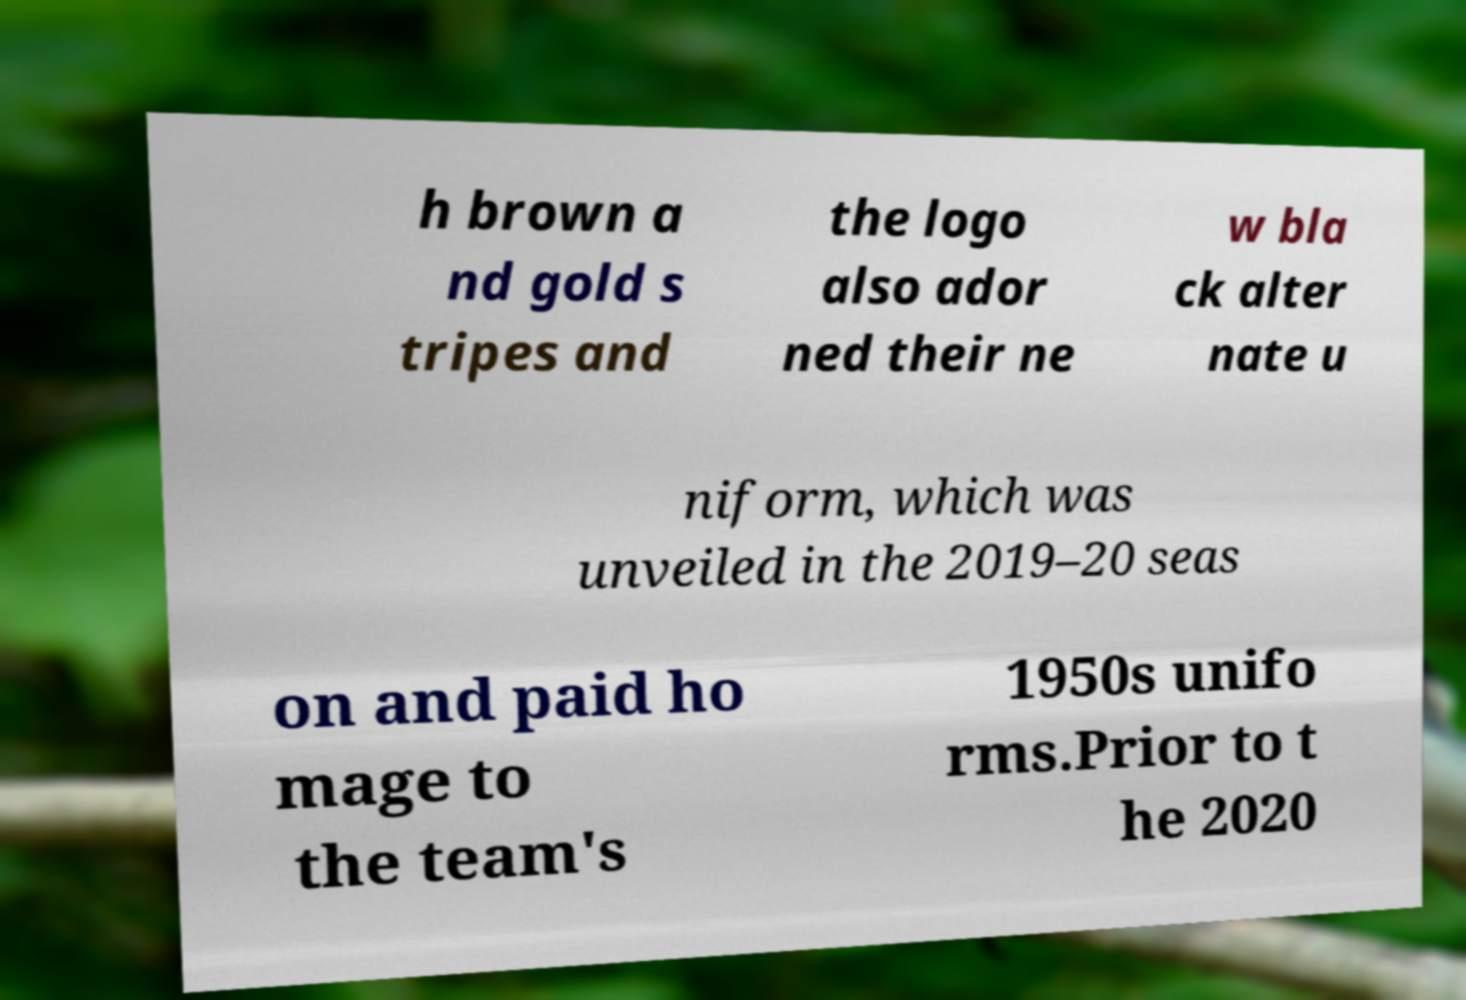Please read and relay the text visible in this image. What does it say? h brown a nd gold s tripes and the logo also ador ned their ne w bla ck alter nate u niform, which was unveiled in the 2019–20 seas on and paid ho mage to the team's 1950s unifo rms.Prior to t he 2020 